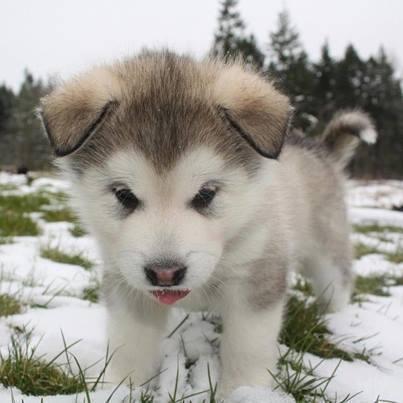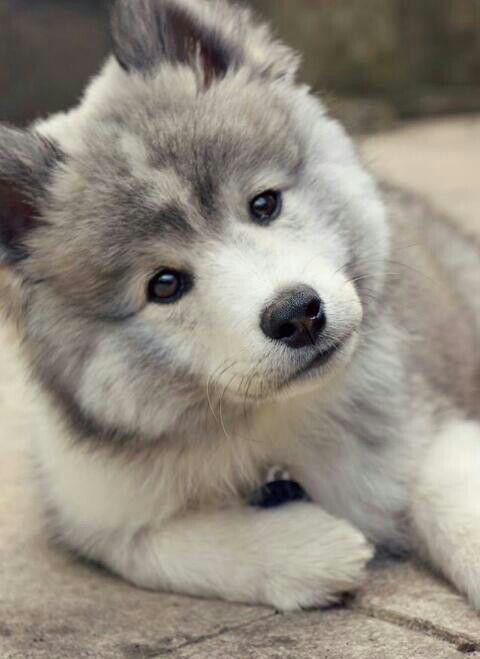The first image is the image on the left, the second image is the image on the right. For the images displayed, is the sentence "The puppy on the left has its tongue visible." factually correct? Answer yes or no. Yes. The first image is the image on the left, the second image is the image on the right. For the images shown, is this caption "One of the two malamutes has its tongue sticking out, while the other is just staring at the camera." true? Answer yes or no. Yes. 